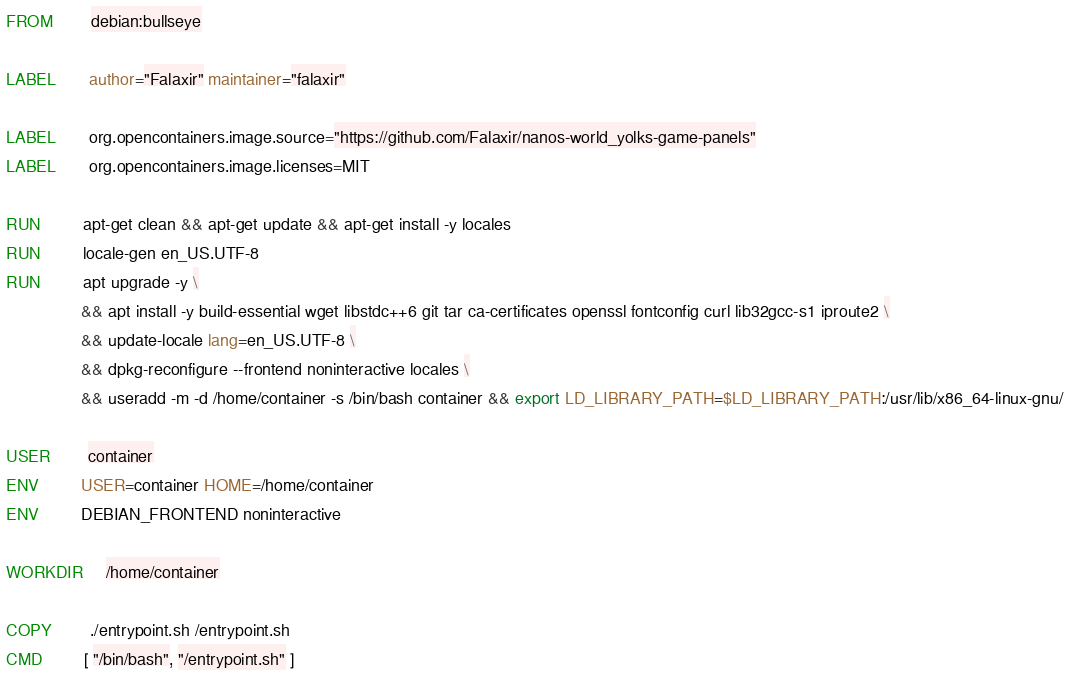Convert code to text. <code><loc_0><loc_0><loc_500><loc_500><_Dockerfile_>FROM        debian:bullseye

LABEL       author="Falaxir" maintainer="falaxir"

LABEL       org.opencontainers.image.source="https://github.com/Falaxir/nanos-world_yolks-game-panels"
LABEL       org.opencontainers.image.licenses=MIT

RUN         apt-get clean && apt-get update && apt-get install -y locales
RUN         locale-gen en_US.UTF-8
RUN         apt upgrade -y \
				&& apt install -y build-essential wget libstdc++6 git tar ca-certificates openssl fontconfig curl lib32gcc-s1 iproute2 \
				&& update-locale lang=en_US.UTF-8 \
				&& dpkg-reconfigure --frontend noninteractive locales \
				&& useradd -m -d /home/container -s /bin/bash container && export LD_LIBRARY_PATH=$LD_LIBRARY_PATH:/usr/lib/x86_64-linux-gnu/

USER        container
ENV         USER=container HOME=/home/container
ENV         DEBIAN_FRONTEND noninteractive

WORKDIR     /home/container

COPY        ./entrypoint.sh /entrypoint.sh
CMD         [ "/bin/bash", "/entrypoint.sh" ]
</code> 